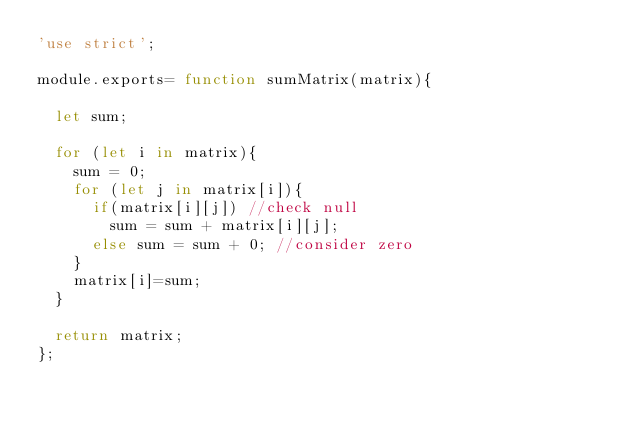<code> <loc_0><loc_0><loc_500><loc_500><_JavaScript_>'use strict';

module.exports= function sumMatrix(matrix){

  let sum;

  for (let i in matrix){
    sum = 0;
    for (let j in matrix[i]){
      if(matrix[i][j]) //check null
        sum = sum + matrix[i][j];
      else sum = sum + 0; //consider zero
    }
    matrix[i]=sum;
  }

  return matrix;
};
</code> 